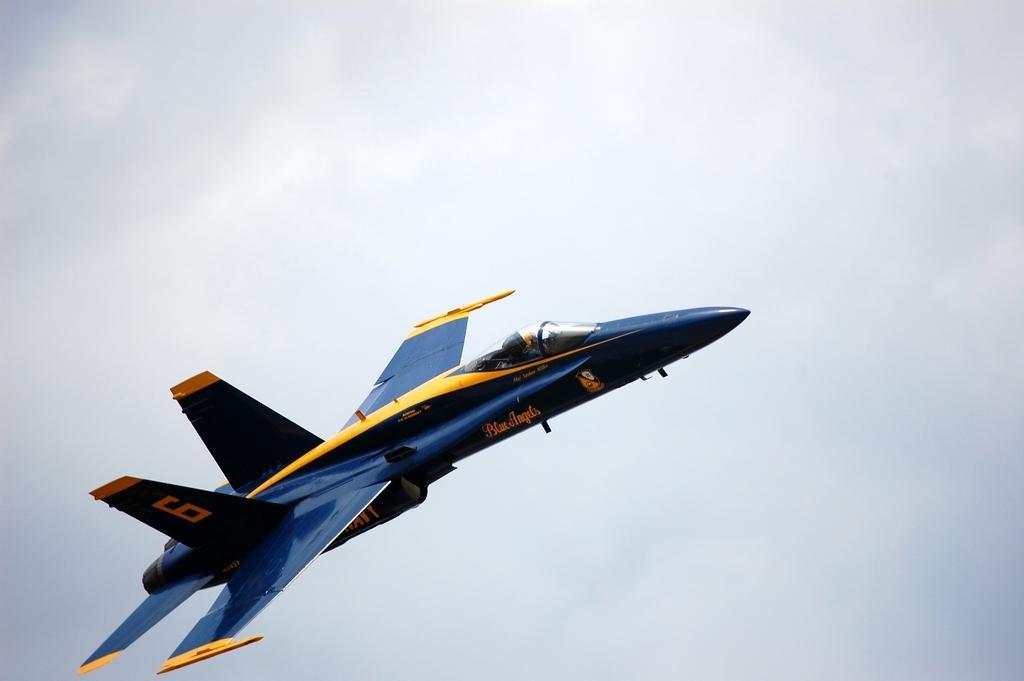Could you give a brief overview of what you see in this image? This image consists of a plane in blue color. It is in the air. In the background, we can see clouds in the sky. 